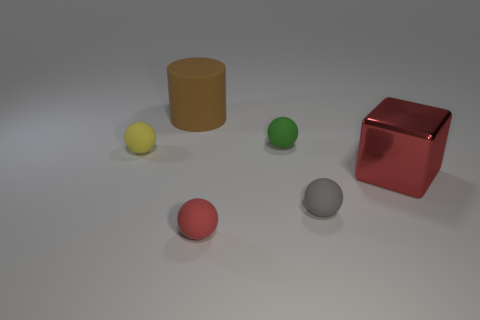Are the red thing in front of the big red shiny object and the brown thing made of the same material?
Keep it short and to the point. Yes. The small ball that is both behind the tiny red matte object and in front of the yellow sphere is made of what material?
Your answer should be compact. Rubber. The tiny rubber ball on the left side of the red thing that is in front of the large red block is what color?
Your answer should be very brief. Yellow. What is the material of the small red object that is the same shape as the yellow rubber object?
Provide a short and direct response. Rubber. There is a big thing behind the large thing that is in front of the big object that is to the left of the shiny cube; what is its color?
Your answer should be compact. Brown. How many objects are either big blue shiny cylinders or red balls?
Make the answer very short. 1. What number of brown objects have the same shape as the gray matte thing?
Offer a very short reply. 0. Is the material of the large red thing the same as the tiny object that is in front of the gray object?
Your response must be concise. No. There is a gray thing that is made of the same material as the yellow ball; what size is it?
Give a very brief answer. Small. There is a sphere behind the yellow object; how big is it?
Offer a terse response. Small. 